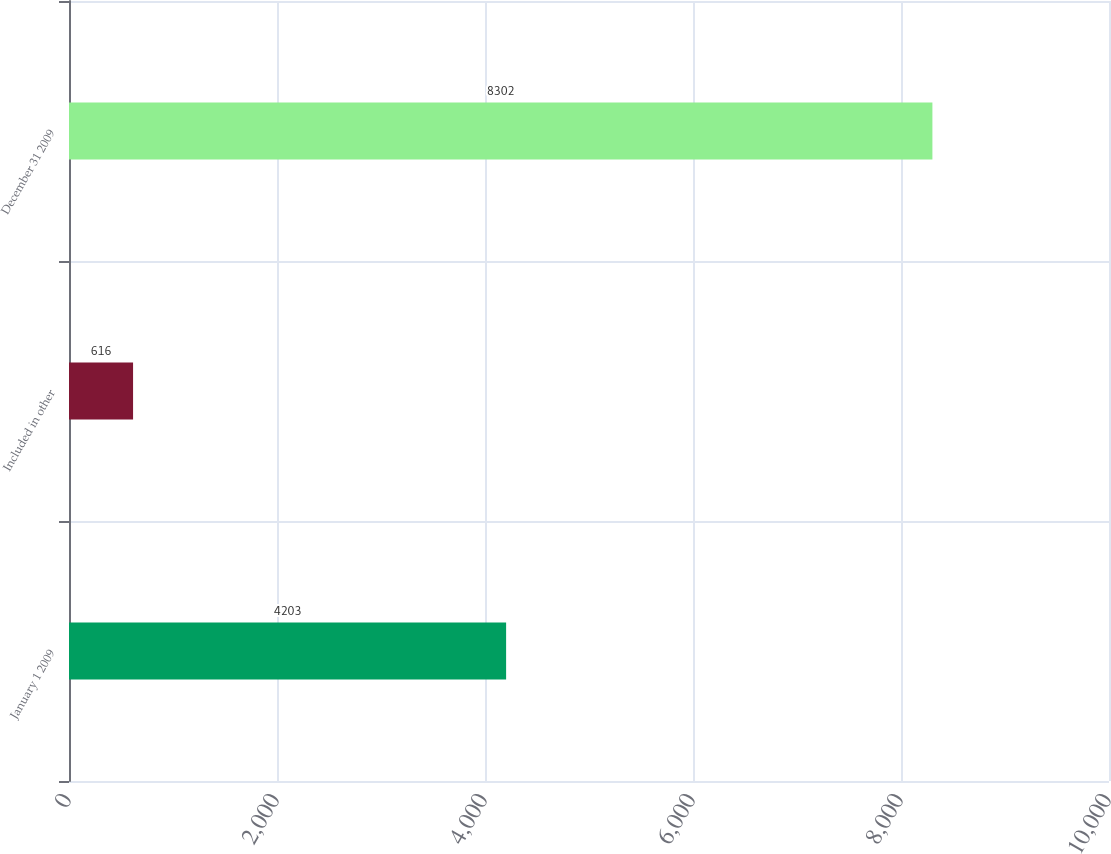Convert chart. <chart><loc_0><loc_0><loc_500><loc_500><bar_chart><fcel>January 1 2009<fcel>Included in other<fcel>December 31 2009<nl><fcel>4203<fcel>616<fcel>8302<nl></chart> 